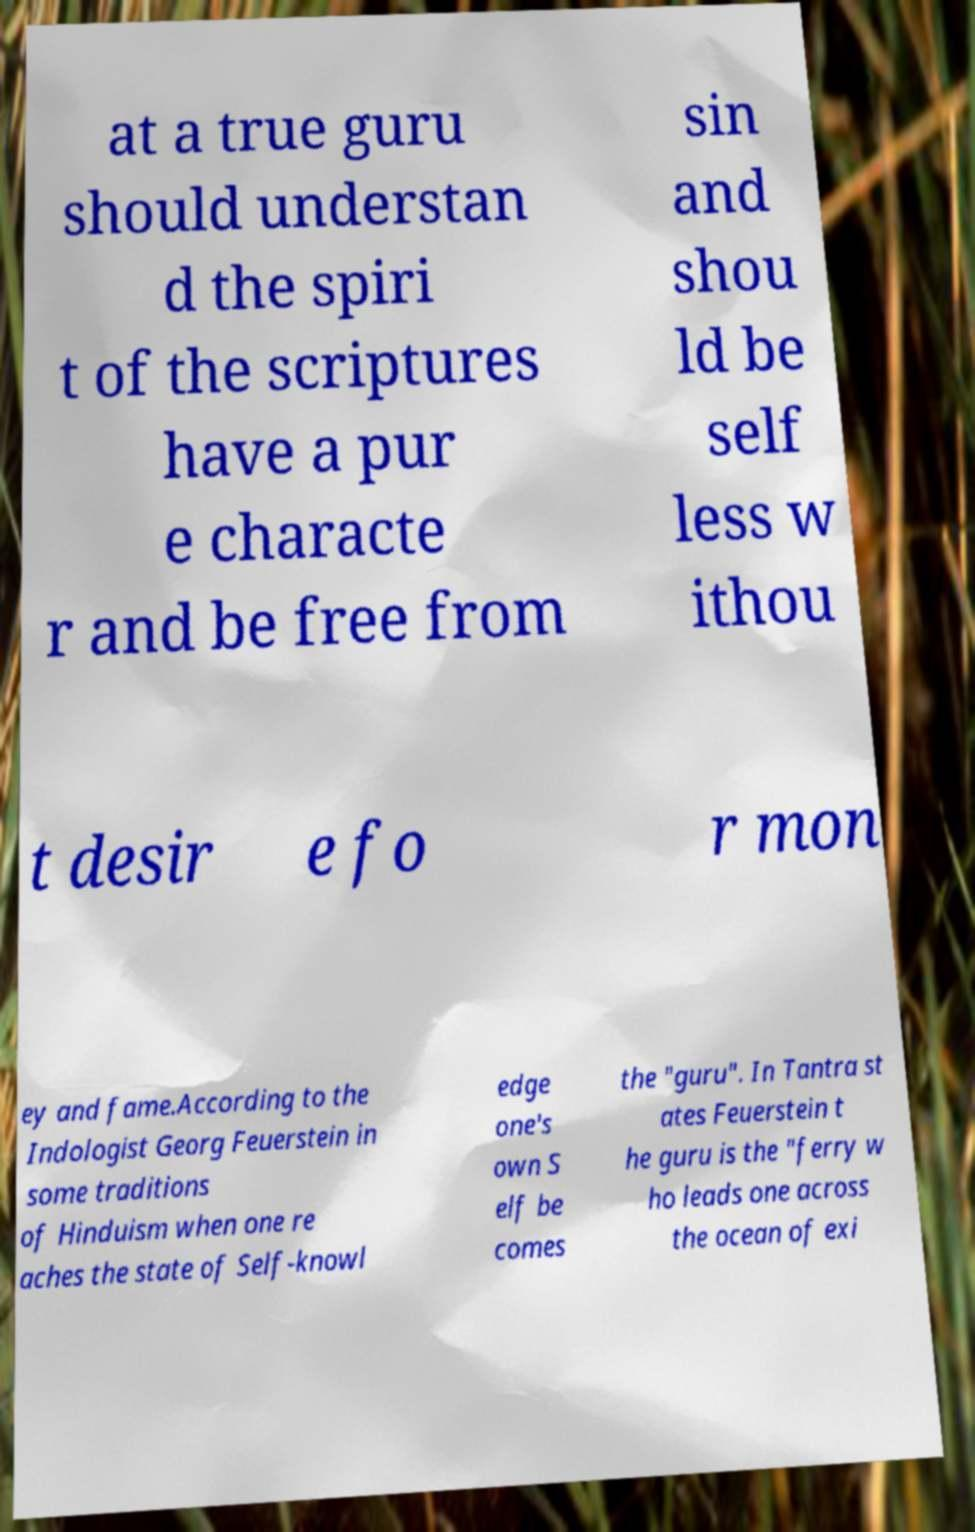Can you accurately transcribe the text from the provided image for me? at a true guru should understan d the spiri t of the scriptures have a pur e characte r and be free from sin and shou ld be self less w ithou t desir e fo r mon ey and fame.According to the Indologist Georg Feuerstein in some traditions of Hinduism when one re aches the state of Self-knowl edge one's own S elf be comes the "guru". In Tantra st ates Feuerstein t he guru is the "ferry w ho leads one across the ocean of exi 